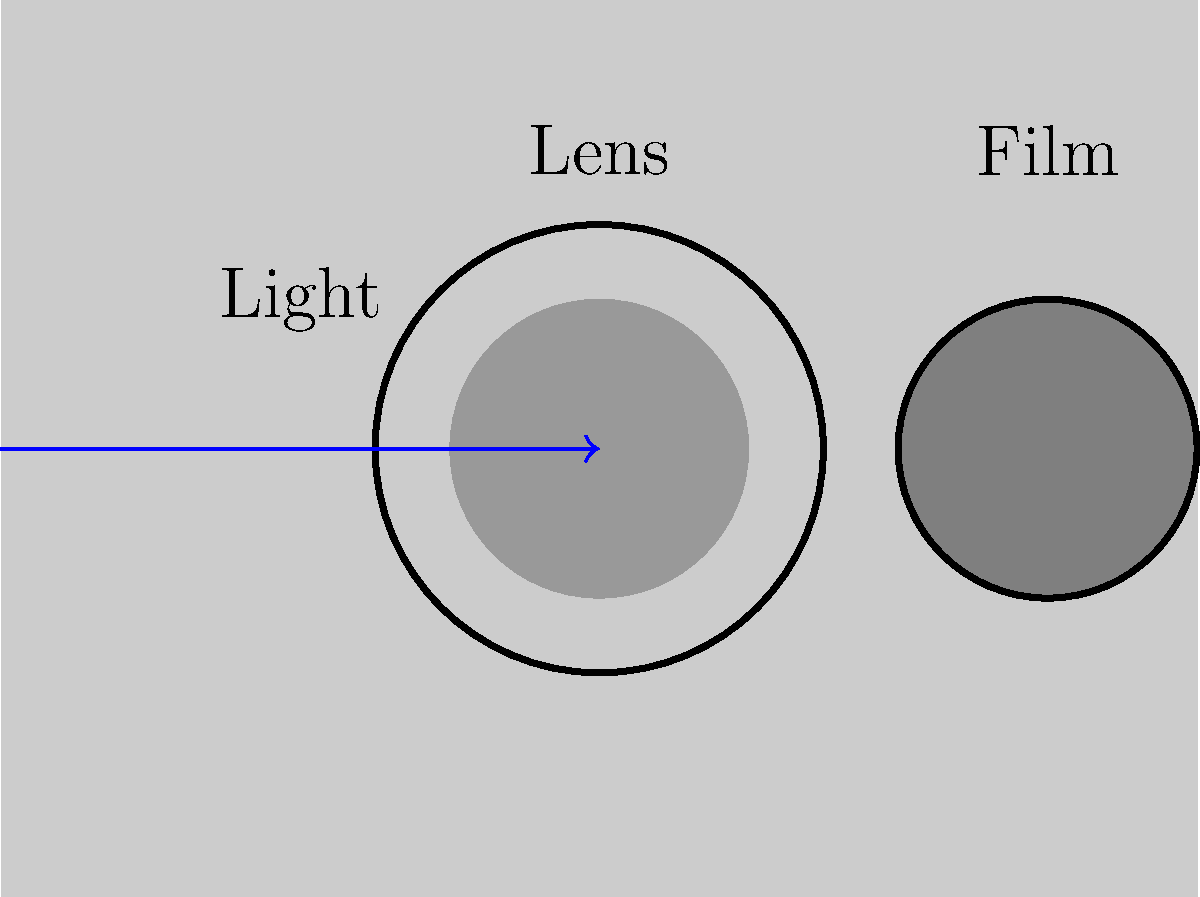In early film cameras, light passing through the lens would expose the film to create an image. Considering the physics of optics, what property of the lens was crucial for focusing the image correctly on the film, and how did this relate to the historical development of cinematography? 1. The crucial property of the lens for focusing the image correctly on the film is its focal length.

2. The focal length is the distance between the lens and the point where light rays converge to form a sharp image.

3. In early film cameras, the focal length determined:
   a) The field of view: Shorter focal lengths provided wider angles, while longer focal lengths gave narrower, more magnified views.
   b) The depth of field: Shorter focal lengths generally provided greater depth of field, allowing more of the scene to be in focus.

4. Historically, the development of cinematography was influenced by advancements in lens technology:
   a) Early films often used fixed focal length lenses, limiting compositional options.
   b) The invention of zoom lenses in the 1920s allowed for more dynamic shots and camera movements.
   c) Improvements in lens coating and design reduced aberrations, enhancing image quality.

5. Understanding and manipulating focal length became a crucial skill for cinematographers:
   a) It allowed for creative framing and composition.
   b) It helped in creating specific visual effects or moods.

6. The interplay between focal length and aperture also affected exposure, which was particularly important in early film when film stocks were less sensitive.

7. As film technology evolved, cinematographers could leverage a wider range of focal lengths to tell stories more effectively, showcasing the importance of this physical property in the historical context of filmmaking.
Answer: Focal length 